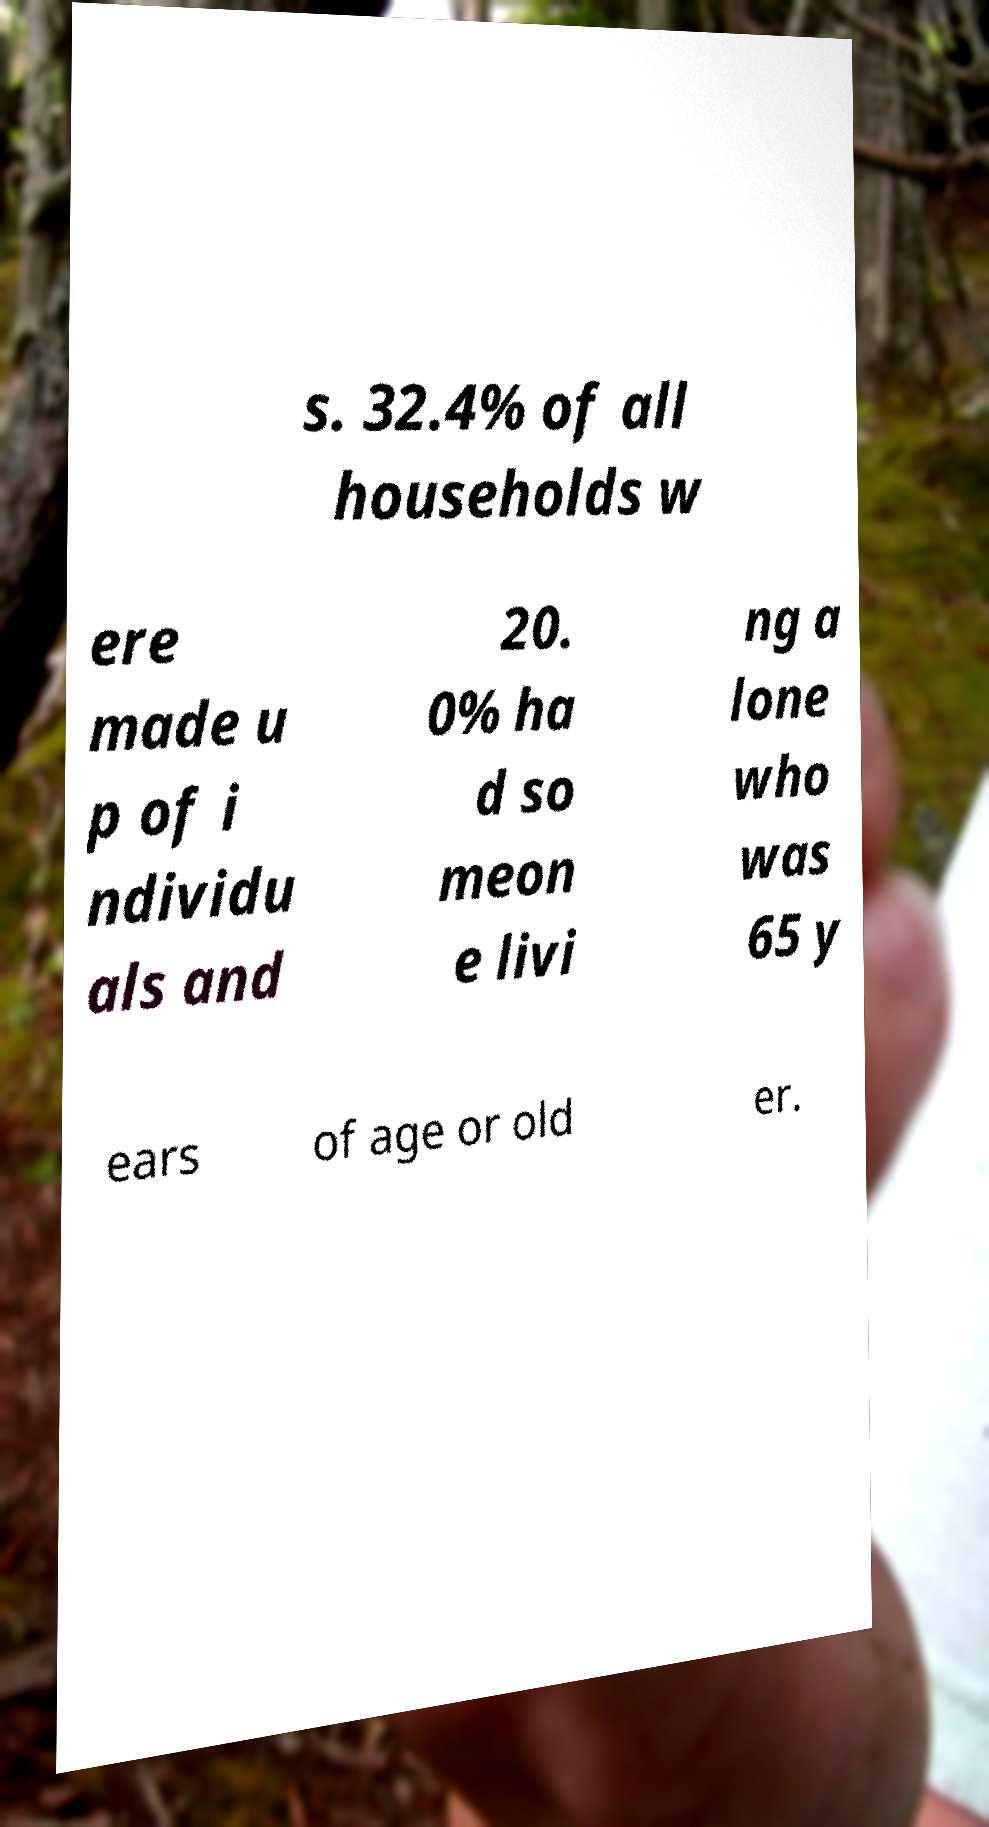Please identify and transcribe the text found in this image. s. 32.4% of all households w ere made u p of i ndividu als and 20. 0% ha d so meon e livi ng a lone who was 65 y ears of age or old er. 